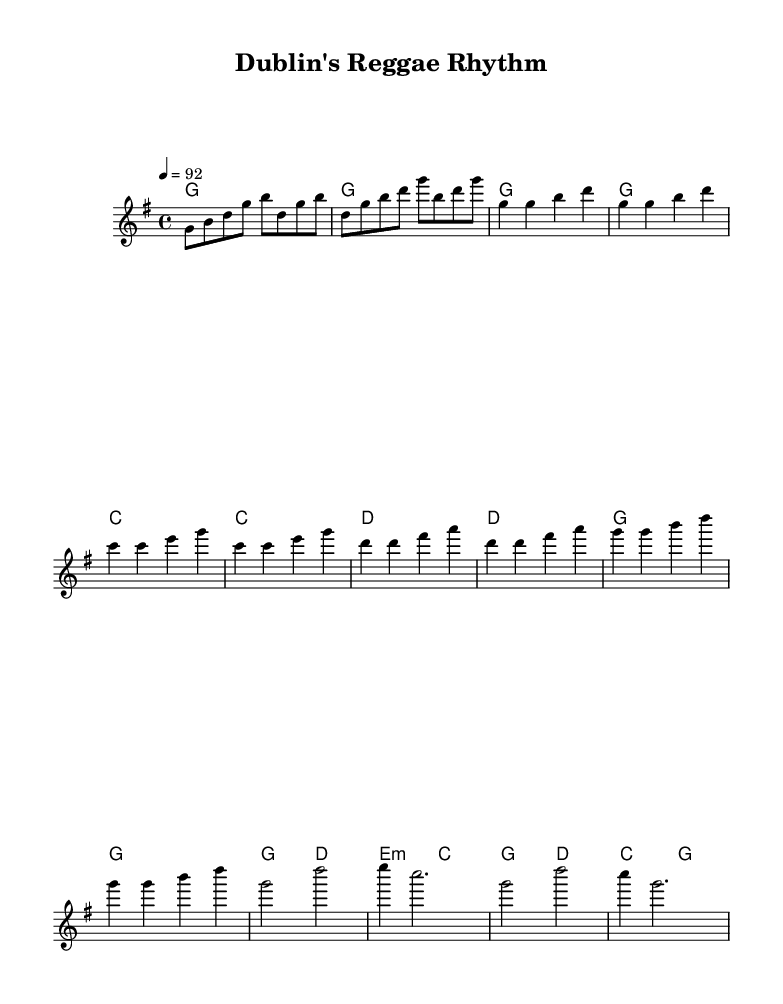What is the key signature of this music? The key signature is G major, which has one sharp (F sharp).
Answer: G major What is the time signature of this music? The time signature is 4/4, meaning there are four beats in each measure.
Answer: 4/4 What is the tempo marking of this music? The tempo marking is 92 beats per minute.
Answer: 92 How many measures are in the chorus section? The chorus section consists of four measures, as indicated by the measures counted in the score.
Answer: 4 What is the main theme expressed in the lyrics? The main theme is about Irish heritage and pride, combining elements from Dublin and reggae music.
Answer: Irish heritage and pride Which section of the music includes the lyrics "Dublin's reggae rhythm, feel the Celtic pride"? This lyric is part of the chorus section of the music, clearly marked in the score.
Answer: Chorus 